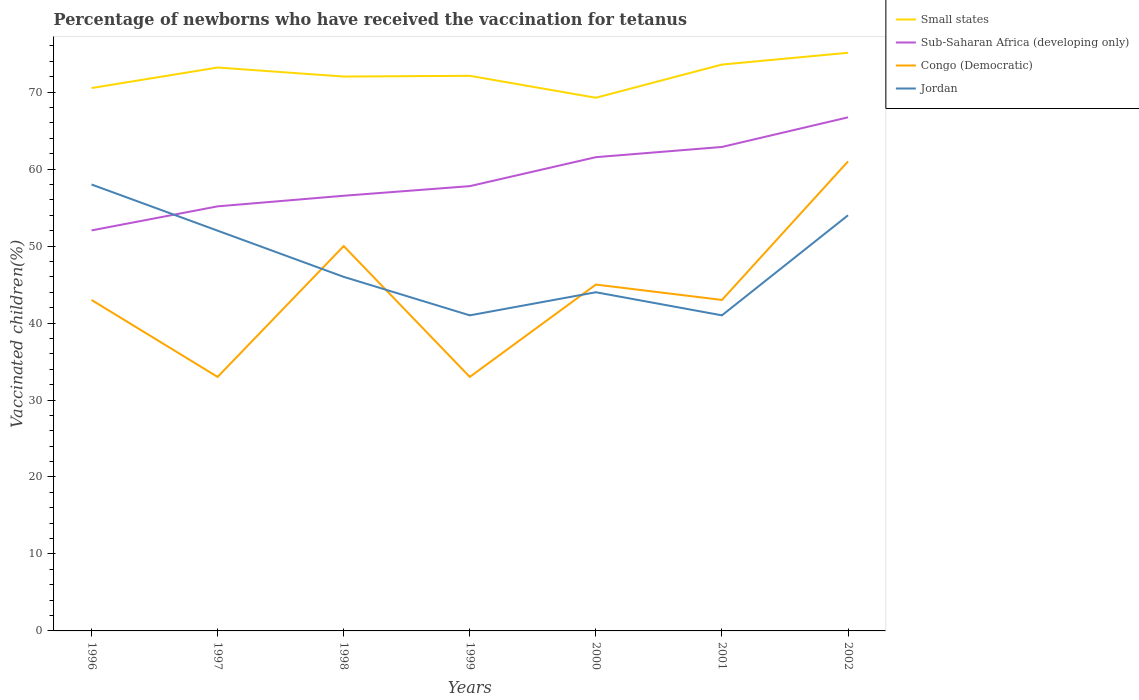How many different coloured lines are there?
Offer a very short reply. 4. Does the line corresponding to Congo (Democratic) intersect with the line corresponding to Small states?
Keep it short and to the point. No. In which year was the percentage of vaccinated children in Jordan maximum?
Your answer should be very brief. 1999. What is the total percentage of vaccinated children in Congo (Democratic) in the graph?
Offer a very short reply. -18. What is the difference between the highest and the second highest percentage of vaccinated children in Small states?
Make the answer very short. 5.84. Is the percentage of vaccinated children in Small states strictly greater than the percentage of vaccinated children in Sub-Saharan Africa (developing only) over the years?
Ensure brevity in your answer.  No. How many legend labels are there?
Offer a terse response. 4. What is the title of the graph?
Your answer should be very brief. Percentage of newborns who have received the vaccination for tetanus. What is the label or title of the Y-axis?
Offer a very short reply. Vaccinated children(%). What is the Vaccinated children(%) of Small states in 1996?
Keep it short and to the point. 70.53. What is the Vaccinated children(%) of Sub-Saharan Africa (developing only) in 1996?
Your answer should be compact. 52.04. What is the Vaccinated children(%) in Congo (Democratic) in 1996?
Give a very brief answer. 43. What is the Vaccinated children(%) of Jordan in 1996?
Keep it short and to the point. 58. What is the Vaccinated children(%) of Small states in 1997?
Provide a succinct answer. 73.2. What is the Vaccinated children(%) in Sub-Saharan Africa (developing only) in 1997?
Keep it short and to the point. 55.16. What is the Vaccinated children(%) in Congo (Democratic) in 1997?
Offer a very short reply. 33. What is the Vaccinated children(%) in Small states in 1998?
Keep it short and to the point. 72.03. What is the Vaccinated children(%) in Sub-Saharan Africa (developing only) in 1998?
Keep it short and to the point. 56.54. What is the Vaccinated children(%) of Congo (Democratic) in 1998?
Ensure brevity in your answer.  50. What is the Vaccinated children(%) in Small states in 1999?
Ensure brevity in your answer.  72.12. What is the Vaccinated children(%) of Sub-Saharan Africa (developing only) in 1999?
Keep it short and to the point. 57.79. What is the Vaccinated children(%) in Congo (Democratic) in 1999?
Ensure brevity in your answer.  33. What is the Vaccinated children(%) in Jordan in 1999?
Offer a terse response. 41. What is the Vaccinated children(%) of Small states in 2000?
Your answer should be very brief. 69.27. What is the Vaccinated children(%) of Sub-Saharan Africa (developing only) in 2000?
Your response must be concise. 61.55. What is the Vaccinated children(%) in Congo (Democratic) in 2000?
Keep it short and to the point. 45. What is the Vaccinated children(%) in Jordan in 2000?
Provide a succinct answer. 44. What is the Vaccinated children(%) in Small states in 2001?
Offer a terse response. 73.58. What is the Vaccinated children(%) in Sub-Saharan Africa (developing only) in 2001?
Make the answer very short. 62.88. What is the Vaccinated children(%) of Small states in 2002?
Make the answer very short. 75.11. What is the Vaccinated children(%) in Sub-Saharan Africa (developing only) in 2002?
Give a very brief answer. 66.73. Across all years, what is the maximum Vaccinated children(%) in Small states?
Your answer should be compact. 75.11. Across all years, what is the maximum Vaccinated children(%) in Sub-Saharan Africa (developing only)?
Your response must be concise. 66.73. Across all years, what is the maximum Vaccinated children(%) in Jordan?
Your response must be concise. 58. Across all years, what is the minimum Vaccinated children(%) of Small states?
Make the answer very short. 69.27. Across all years, what is the minimum Vaccinated children(%) in Sub-Saharan Africa (developing only)?
Provide a short and direct response. 52.04. Across all years, what is the minimum Vaccinated children(%) in Congo (Democratic)?
Ensure brevity in your answer.  33. What is the total Vaccinated children(%) in Small states in the graph?
Your response must be concise. 505.84. What is the total Vaccinated children(%) in Sub-Saharan Africa (developing only) in the graph?
Keep it short and to the point. 412.67. What is the total Vaccinated children(%) in Congo (Democratic) in the graph?
Make the answer very short. 308. What is the total Vaccinated children(%) in Jordan in the graph?
Your answer should be compact. 336. What is the difference between the Vaccinated children(%) in Small states in 1996 and that in 1997?
Offer a very short reply. -2.67. What is the difference between the Vaccinated children(%) in Sub-Saharan Africa (developing only) in 1996 and that in 1997?
Provide a succinct answer. -3.13. What is the difference between the Vaccinated children(%) in Congo (Democratic) in 1996 and that in 1997?
Ensure brevity in your answer.  10. What is the difference between the Vaccinated children(%) of Small states in 1996 and that in 1998?
Your answer should be very brief. -1.49. What is the difference between the Vaccinated children(%) in Sub-Saharan Africa (developing only) in 1996 and that in 1998?
Provide a succinct answer. -4.5. What is the difference between the Vaccinated children(%) in Congo (Democratic) in 1996 and that in 1998?
Ensure brevity in your answer.  -7. What is the difference between the Vaccinated children(%) in Small states in 1996 and that in 1999?
Your answer should be compact. -1.59. What is the difference between the Vaccinated children(%) of Sub-Saharan Africa (developing only) in 1996 and that in 1999?
Provide a succinct answer. -5.75. What is the difference between the Vaccinated children(%) of Congo (Democratic) in 1996 and that in 1999?
Provide a short and direct response. 10. What is the difference between the Vaccinated children(%) of Small states in 1996 and that in 2000?
Offer a very short reply. 1.26. What is the difference between the Vaccinated children(%) in Sub-Saharan Africa (developing only) in 1996 and that in 2000?
Your answer should be compact. -9.51. What is the difference between the Vaccinated children(%) in Congo (Democratic) in 1996 and that in 2000?
Keep it short and to the point. -2. What is the difference between the Vaccinated children(%) in Small states in 1996 and that in 2001?
Offer a very short reply. -3.05. What is the difference between the Vaccinated children(%) of Sub-Saharan Africa (developing only) in 1996 and that in 2001?
Ensure brevity in your answer.  -10.84. What is the difference between the Vaccinated children(%) of Congo (Democratic) in 1996 and that in 2001?
Provide a succinct answer. 0. What is the difference between the Vaccinated children(%) of Small states in 1996 and that in 2002?
Ensure brevity in your answer.  -4.58. What is the difference between the Vaccinated children(%) of Sub-Saharan Africa (developing only) in 1996 and that in 2002?
Offer a terse response. -14.69. What is the difference between the Vaccinated children(%) of Congo (Democratic) in 1996 and that in 2002?
Give a very brief answer. -18. What is the difference between the Vaccinated children(%) of Jordan in 1996 and that in 2002?
Offer a terse response. 4. What is the difference between the Vaccinated children(%) of Small states in 1997 and that in 1998?
Your answer should be very brief. 1.17. What is the difference between the Vaccinated children(%) of Sub-Saharan Africa (developing only) in 1997 and that in 1998?
Your response must be concise. -1.38. What is the difference between the Vaccinated children(%) in Jordan in 1997 and that in 1998?
Offer a very short reply. 6. What is the difference between the Vaccinated children(%) in Small states in 1997 and that in 1999?
Give a very brief answer. 1.08. What is the difference between the Vaccinated children(%) in Sub-Saharan Africa (developing only) in 1997 and that in 1999?
Offer a very short reply. -2.62. What is the difference between the Vaccinated children(%) in Congo (Democratic) in 1997 and that in 1999?
Keep it short and to the point. 0. What is the difference between the Vaccinated children(%) in Jordan in 1997 and that in 1999?
Make the answer very short. 11. What is the difference between the Vaccinated children(%) of Small states in 1997 and that in 2000?
Ensure brevity in your answer.  3.93. What is the difference between the Vaccinated children(%) of Sub-Saharan Africa (developing only) in 1997 and that in 2000?
Your answer should be compact. -6.39. What is the difference between the Vaccinated children(%) in Congo (Democratic) in 1997 and that in 2000?
Your response must be concise. -12. What is the difference between the Vaccinated children(%) of Jordan in 1997 and that in 2000?
Keep it short and to the point. 8. What is the difference between the Vaccinated children(%) in Small states in 1997 and that in 2001?
Ensure brevity in your answer.  -0.38. What is the difference between the Vaccinated children(%) in Sub-Saharan Africa (developing only) in 1997 and that in 2001?
Keep it short and to the point. -7.72. What is the difference between the Vaccinated children(%) in Jordan in 1997 and that in 2001?
Give a very brief answer. 11. What is the difference between the Vaccinated children(%) of Small states in 1997 and that in 2002?
Ensure brevity in your answer.  -1.92. What is the difference between the Vaccinated children(%) in Sub-Saharan Africa (developing only) in 1997 and that in 2002?
Your answer should be compact. -11.57. What is the difference between the Vaccinated children(%) of Small states in 1998 and that in 1999?
Keep it short and to the point. -0.09. What is the difference between the Vaccinated children(%) of Sub-Saharan Africa (developing only) in 1998 and that in 1999?
Offer a terse response. -1.25. What is the difference between the Vaccinated children(%) of Small states in 1998 and that in 2000?
Make the answer very short. 2.75. What is the difference between the Vaccinated children(%) of Sub-Saharan Africa (developing only) in 1998 and that in 2000?
Your answer should be very brief. -5.01. What is the difference between the Vaccinated children(%) of Congo (Democratic) in 1998 and that in 2000?
Your response must be concise. 5. What is the difference between the Vaccinated children(%) in Jordan in 1998 and that in 2000?
Keep it short and to the point. 2. What is the difference between the Vaccinated children(%) of Small states in 1998 and that in 2001?
Offer a terse response. -1.56. What is the difference between the Vaccinated children(%) in Sub-Saharan Africa (developing only) in 1998 and that in 2001?
Offer a terse response. -6.34. What is the difference between the Vaccinated children(%) in Congo (Democratic) in 1998 and that in 2001?
Offer a very short reply. 7. What is the difference between the Vaccinated children(%) in Small states in 1998 and that in 2002?
Offer a terse response. -3.09. What is the difference between the Vaccinated children(%) of Sub-Saharan Africa (developing only) in 1998 and that in 2002?
Offer a very short reply. -10.19. What is the difference between the Vaccinated children(%) of Jordan in 1998 and that in 2002?
Make the answer very short. -8. What is the difference between the Vaccinated children(%) in Small states in 1999 and that in 2000?
Make the answer very short. 2.85. What is the difference between the Vaccinated children(%) of Sub-Saharan Africa (developing only) in 1999 and that in 2000?
Offer a very short reply. -3.76. What is the difference between the Vaccinated children(%) in Small states in 1999 and that in 2001?
Offer a terse response. -1.46. What is the difference between the Vaccinated children(%) in Sub-Saharan Africa (developing only) in 1999 and that in 2001?
Provide a short and direct response. -5.09. What is the difference between the Vaccinated children(%) in Jordan in 1999 and that in 2001?
Offer a very short reply. 0. What is the difference between the Vaccinated children(%) in Small states in 1999 and that in 2002?
Provide a succinct answer. -2.99. What is the difference between the Vaccinated children(%) of Sub-Saharan Africa (developing only) in 1999 and that in 2002?
Ensure brevity in your answer.  -8.94. What is the difference between the Vaccinated children(%) in Jordan in 1999 and that in 2002?
Offer a very short reply. -13. What is the difference between the Vaccinated children(%) of Small states in 2000 and that in 2001?
Your response must be concise. -4.31. What is the difference between the Vaccinated children(%) in Sub-Saharan Africa (developing only) in 2000 and that in 2001?
Make the answer very short. -1.33. What is the difference between the Vaccinated children(%) of Small states in 2000 and that in 2002?
Provide a succinct answer. -5.84. What is the difference between the Vaccinated children(%) in Sub-Saharan Africa (developing only) in 2000 and that in 2002?
Your answer should be very brief. -5.18. What is the difference between the Vaccinated children(%) of Jordan in 2000 and that in 2002?
Ensure brevity in your answer.  -10. What is the difference between the Vaccinated children(%) of Small states in 2001 and that in 2002?
Make the answer very short. -1.53. What is the difference between the Vaccinated children(%) of Sub-Saharan Africa (developing only) in 2001 and that in 2002?
Keep it short and to the point. -3.85. What is the difference between the Vaccinated children(%) in Congo (Democratic) in 2001 and that in 2002?
Give a very brief answer. -18. What is the difference between the Vaccinated children(%) in Small states in 1996 and the Vaccinated children(%) in Sub-Saharan Africa (developing only) in 1997?
Your response must be concise. 15.37. What is the difference between the Vaccinated children(%) in Small states in 1996 and the Vaccinated children(%) in Congo (Democratic) in 1997?
Your response must be concise. 37.53. What is the difference between the Vaccinated children(%) in Small states in 1996 and the Vaccinated children(%) in Jordan in 1997?
Your answer should be very brief. 18.53. What is the difference between the Vaccinated children(%) in Sub-Saharan Africa (developing only) in 1996 and the Vaccinated children(%) in Congo (Democratic) in 1997?
Make the answer very short. 19.04. What is the difference between the Vaccinated children(%) of Sub-Saharan Africa (developing only) in 1996 and the Vaccinated children(%) of Jordan in 1997?
Your answer should be very brief. 0.04. What is the difference between the Vaccinated children(%) in Small states in 1996 and the Vaccinated children(%) in Sub-Saharan Africa (developing only) in 1998?
Offer a very short reply. 13.99. What is the difference between the Vaccinated children(%) of Small states in 1996 and the Vaccinated children(%) of Congo (Democratic) in 1998?
Keep it short and to the point. 20.53. What is the difference between the Vaccinated children(%) in Small states in 1996 and the Vaccinated children(%) in Jordan in 1998?
Offer a terse response. 24.53. What is the difference between the Vaccinated children(%) in Sub-Saharan Africa (developing only) in 1996 and the Vaccinated children(%) in Congo (Democratic) in 1998?
Offer a very short reply. 2.04. What is the difference between the Vaccinated children(%) of Sub-Saharan Africa (developing only) in 1996 and the Vaccinated children(%) of Jordan in 1998?
Provide a short and direct response. 6.04. What is the difference between the Vaccinated children(%) in Congo (Democratic) in 1996 and the Vaccinated children(%) in Jordan in 1998?
Your response must be concise. -3. What is the difference between the Vaccinated children(%) of Small states in 1996 and the Vaccinated children(%) of Sub-Saharan Africa (developing only) in 1999?
Provide a succinct answer. 12.75. What is the difference between the Vaccinated children(%) in Small states in 1996 and the Vaccinated children(%) in Congo (Democratic) in 1999?
Provide a short and direct response. 37.53. What is the difference between the Vaccinated children(%) of Small states in 1996 and the Vaccinated children(%) of Jordan in 1999?
Offer a terse response. 29.53. What is the difference between the Vaccinated children(%) in Sub-Saharan Africa (developing only) in 1996 and the Vaccinated children(%) in Congo (Democratic) in 1999?
Make the answer very short. 19.04. What is the difference between the Vaccinated children(%) of Sub-Saharan Africa (developing only) in 1996 and the Vaccinated children(%) of Jordan in 1999?
Offer a very short reply. 11.04. What is the difference between the Vaccinated children(%) in Small states in 1996 and the Vaccinated children(%) in Sub-Saharan Africa (developing only) in 2000?
Provide a succinct answer. 8.98. What is the difference between the Vaccinated children(%) in Small states in 1996 and the Vaccinated children(%) in Congo (Democratic) in 2000?
Keep it short and to the point. 25.53. What is the difference between the Vaccinated children(%) in Small states in 1996 and the Vaccinated children(%) in Jordan in 2000?
Provide a short and direct response. 26.53. What is the difference between the Vaccinated children(%) of Sub-Saharan Africa (developing only) in 1996 and the Vaccinated children(%) of Congo (Democratic) in 2000?
Give a very brief answer. 7.04. What is the difference between the Vaccinated children(%) of Sub-Saharan Africa (developing only) in 1996 and the Vaccinated children(%) of Jordan in 2000?
Offer a terse response. 8.04. What is the difference between the Vaccinated children(%) in Congo (Democratic) in 1996 and the Vaccinated children(%) in Jordan in 2000?
Make the answer very short. -1. What is the difference between the Vaccinated children(%) of Small states in 1996 and the Vaccinated children(%) of Sub-Saharan Africa (developing only) in 2001?
Your answer should be very brief. 7.65. What is the difference between the Vaccinated children(%) of Small states in 1996 and the Vaccinated children(%) of Congo (Democratic) in 2001?
Make the answer very short. 27.53. What is the difference between the Vaccinated children(%) of Small states in 1996 and the Vaccinated children(%) of Jordan in 2001?
Ensure brevity in your answer.  29.53. What is the difference between the Vaccinated children(%) in Sub-Saharan Africa (developing only) in 1996 and the Vaccinated children(%) in Congo (Democratic) in 2001?
Give a very brief answer. 9.04. What is the difference between the Vaccinated children(%) of Sub-Saharan Africa (developing only) in 1996 and the Vaccinated children(%) of Jordan in 2001?
Offer a very short reply. 11.04. What is the difference between the Vaccinated children(%) of Congo (Democratic) in 1996 and the Vaccinated children(%) of Jordan in 2001?
Provide a succinct answer. 2. What is the difference between the Vaccinated children(%) of Small states in 1996 and the Vaccinated children(%) of Sub-Saharan Africa (developing only) in 2002?
Offer a very short reply. 3.8. What is the difference between the Vaccinated children(%) in Small states in 1996 and the Vaccinated children(%) in Congo (Democratic) in 2002?
Offer a terse response. 9.53. What is the difference between the Vaccinated children(%) of Small states in 1996 and the Vaccinated children(%) of Jordan in 2002?
Provide a succinct answer. 16.53. What is the difference between the Vaccinated children(%) in Sub-Saharan Africa (developing only) in 1996 and the Vaccinated children(%) in Congo (Democratic) in 2002?
Offer a terse response. -8.96. What is the difference between the Vaccinated children(%) in Sub-Saharan Africa (developing only) in 1996 and the Vaccinated children(%) in Jordan in 2002?
Ensure brevity in your answer.  -1.96. What is the difference between the Vaccinated children(%) in Small states in 1997 and the Vaccinated children(%) in Sub-Saharan Africa (developing only) in 1998?
Your response must be concise. 16.66. What is the difference between the Vaccinated children(%) in Small states in 1997 and the Vaccinated children(%) in Congo (Democratic) in 1998?
Keep it short and to the point. 23.2. What is the difference between the Vaccinated children(%) of Small states in 1997 and the Vaccinated children(%) of Jordan in 1998?
Offer a very short reply. 27.2. What is the difference between the Vaccinated children(%) of Sub-Saharan Africa (developing only) in 1997 and the Vaccinated children(%) of Congo (Democratic) in 1998?
Your answer should be very brief. 5.16. What is the difference between the Vaccinated children(%) of Sub-Saharan Africa (developing only) in 1997 and the Vaccinated children(%) of Jordan in 1998?
Your response must be concise. 9.16. What is the difference between the Vaccinated children(%) of Congo (Democratic) in 1997 and the Vaccinated children(%) of Jordan in 1998?
Your answer should be compact. -13. What is the difference between the Vaccinated children(%) of Small states in 1997 and the Vaccinated children(%) of Sub-Saharan Africa (developing only) in 1999?
Make the answer very short. 15.41. What is the difference between the Vaccinated children(%) of Small states in 1997 and the Vaccinated children(%) of Congo (Democratic) in 1999?
Your answer should be very brief. 40.2. What is the difference between the Vaccinated children(%) in Small states in 1997 and the Vaccinated children(%) in Jordan in 1999?
Your answer should be compact. 32.2. What is the difference between the Vaccinated children(%) in Sub-Saharan Africa (developing only) in 1997 and the Vaccinated children(%) in Congo (Democratic) in 1999?
Make the answer very short. 22.16. What is the difference between the Vaccinated children(%) in Sub-Saharan Africa (developing only) in 1997 and the Vaccinated children(%) in Jordan in 1999?
Offer a terse response. 14.16. What is the difference between the Vaccinated children(%) in Small states in 1997 and the Vaccinated children(%) in Sub-Saharan Africa (developing only) in 2000?
Your answer should be compact. 11.65. What is the difference between the Vaccinated children(%) in Small states in 1997 and the Vaccinated children(%) in Congo (Democratic) in 2000?
Provide a succinct answer. 28.2. What is the difference between the Vaccinated children(%) in Small states in 1997 and the Vaccinated children(%) in Jordan in 2000?
Your answer should be very brief. 29.2. What is the difference between the Vaccinated children(%) of Sub-Saharan Africa (developing only) in 1997 and the Vaccinated children(%) of Congo (Democratic) in 2000?
Provide a short and direct response. 10.16. What is the difference between the Vaccinated children(%) in Sub-Saharan Africa (developing only) in 1997 and the Vaccinated children(%) in Jordan in 2000?
Ensure brevity in your answer.  11.16. What is the difference between the Vaccinated children(%) in Small states in 1997 and the Vaccinated children(%) in Sub-Saharan Africa (developing only) in 2001?
Make the answer very short. 10.32. What is the difference between the Vaccinated children(%) in Small states in 1997 and the Vaccinated children(%) in Congo (Democratic) in 2001?
Your answer should be very brief. 30.2. What is the difference between the Vaccinated children(%) of Small states in 1997 and the Vaccinated children(%) of Jordan in 2001?
Your answer should be compact. 32.2. What is the difference between the Vaccinated children(%) of Sub-Saharan Africa (developing only) in 1997 and the Vaccinated children(%) of Congo (Democratic) in 2001?
Provide a short and direct response. 12.16. What is the difference between the Vaccinated children(%) of Sub-Saharan Africa (developing only) in 1997 and the Vaccinated children(%) of Jordan in 2001?
Keep it short and to the point. 14.16. What is the difference between the Vaccinated children(%) of Congo (Democratic) in 1997 and the Vaccinated children(%) of Jordan in 2001?
Offer a terse response. -8. What is the difference between the Vaccinated children(%) of Small states in 1997 and the Vaccinated children(%) of Sub-Saharan Africa (developing only) in 2002?
Offer a terse response. 6.47. What is the difference between the Vaccinated children(%) of Small states in 1997 and the Vaccinated children(%) of Congo (Democratic) in 2002?
Give a very brief answer. 12.2. What is the difference between the Vaccinated children(%) of Small states in 1997 and the Vaccinated children(%) of Jordan in 2002?
Your answer should be compact. 19.2. What is the difference between the Vaccinated children(%) in Sub-Saharan Africa (developing only) in 1997 and the Vaccinated children(%) in Congo (Democratic) in 2002?
Provide a short and direct response. -5.84. What is the difference between the Vaccinated children(%) of Sub-Saharan Africa (developing only) in 1997 and the Vaccinated children(%) of Jordan in 2002?
Keep it short and to the point. 1.16. What is the difference between the Vaccinated children(%) of Congo (Democratic) in 1997 and the Vaccinated children(%) of Jordan in 2002?
Offer a very short reply. -21. What is the difference between the Vaccinated children(%) of Small states in 1998 and the Vaccinated children(%) of Sub-Saharan Africa (developing only) in 1999?
Offer a very short reply. 14.24. What is the difference between the Vaccinated children(%) of Small states in 1998 and the Vaccinated children(%) of Congo (Democratic) in 1999?
Provide a short and direct response. 39.03. What is the difference between the Vaccinated children(%) in Small states in 1998 and the Vaccinated children(%) in Jordan in 1999?
Offer a very short reply. 31.03. What is the difference between the Vaccinated children(%) in Sub-Saharan Africa (developing only) in 1998 and the Vaccinated children(%) in Congo (Democratic) in 1999?
Provide a short and direct response. 23.54. What is the difference between the Vaccinated children(%) of Sub-Saharan Africa (developing only) in 1998 and the Vaccinated children(%) of Jordan in 1999?
Offer a terse response. 15.54. What is the difference between the Vaccinated children(%) of Small states in 1998 and the Vaccinated children(%) of Sub-Saharan Africa (developing only) in 2000?
Make the answer very short. 10.48. What is the difference between the Vaccinated children(%) in Small states in 1998 and the Vaccinated children(%) in Congo (Democratic) in 2000?
Offer a very short reply. 27.03. What is the difference between the Vaccinated children(%) in Small states in 1998 and the Vaccinated children(%) in Jordan in 2000?
Make the answer very short. 28.03. What is the difference between the Vaccinated children(%) in Sub-Saharan Africa (developing only) in 1998 and the Vaccinated children(%) in Congo (Democratic) in 2000?
Make the answer very short. 11.54. What is the difference between the Vaccinated children(%) of Sub-Saharan Africa (developing only) in 1998 and the Vaccinated children(%) of Jordan in 2000?
Keep it short and to the point. 12.54. What is the difference between the Vaccinated children(%) in Small states in 1998 and the Vaccinated children(%) in Sub-Saharan Africa (developing only) in 2001?
Your answer should be very brief. 9.15. What is the difference between the Vaccinated children(%) of Small states in 1998 and the Vaccinated children(%) of Congo (Democratic) in 2001?
Your answer should be very brief. 29.03. What is the difference between the Vaccinated children(%) in Small states in 1998 and the Vaccinated children(%) in Jordan in 2001?
Offer a very short reply. 31.03. What is the difference between the Vaccinated children(%) of Sub-Saharan Africa (developing only) in 1998 and the Vaccinated children(%) of Congo (Democratic) in 2001?
Your answer should be very brief. 13.54. What is the difference between the Vaccinated children(%) of Sub-Saharan Africa (developing only) in 1998 and the Vaccinated children(%) of Jordan in 2001?
Your answer should be compact. 15.54. What is the difference between the Vaccinated children(%) of Small states in 1998 and the Vaccinated children(%) of Sub-Saharan Africa (developing only) in 2002?
Provide a short and direct response. 5.3. What is the difference between the Vaccinated children(%) of Small states in 1998 and the Vaccinated children(%) of Congo (Democratic) in 2002?
Your answer should be very brief. 11.03. What is the difference between the Vaccinated children(%) of Small states in 1998 and the Vaccinated children(%) of Jordan in 2002?
Provide a succinct answer. 18.03. What is the difference between the Vaccinated children(%) of Sub-Saharan Africa (developing only) in 1998 and the Vaccinated children(%) of Congo (Democratic) in 2002?
Your answer should be compact. -4.46. What is the difference between the Vaccinated children(%) in Sub-Saharan Africa (developing only) in 1998 and the Vaccinated children(%) in Jordan in 2002?
Your response must be concise. 2.54. What is the difference between the Vaccinated children(%) in Small states in 1999 and the Vaccinated children(%) in Sub-Saharan Africa (developing only) in 2000?
Keep it short and to the point. 10.57. What is the difference between the Vaccinated children(%) of Small states in 1999 and the Vaccinated children(%) of Congo (Democratic) in 2000?
Your response must be concise. 27.12. What is the difference between the Vaccinated children(%) in Small states in 1999 and the Vaccinated children(%) in Jordan in 2000?
Keep it short and to the point. 28.12. What is the difference between the Vaccinated children(%) in Sub-Saharan Africa (developing only) in 1999 and the Vaccinated children(%) in Congo (Democratic) in 2000?
Your answer should be very brief. 12.79. What is the difference between the Vaccinated children(%) in Sub-Saharan Africa (developing only) in 1999 and the Vaccinated children(%) in Jordan in 2000?
Provide a succinct answer. 13.79. What is the difference between the Vaccinated children(%) of Congo (Democratic) in 1999 and the Vaccinated children(%) of Jordan in 2000?
Your answer should be compact. -11. What is the difference between the Vaccinated children(%) in Small states in 1999 and the Vaccinated children(%) in Sub-Saharan Africa (developing only) in 2001?
Provide a short and direct response. 9.24. What is the difference between the Vaccinated children(%) in Small states in 1999 and the Vaccinated children(%) in Congo (Democratic) in 2001?
Ensure brevity in your answer.  29.12. What is the difference between the Vaccinated children(%) of Small states in 1999 and the Vaccinated children(%) of Jordan in 2001?
Give a very brief answer. 31.12. What is the difference between the Vaccinated children(%) of Sub-Saharan Africa (developing only) in 1999 and the Vaccinated children(%) of Congo (Democratic) in 2001?
Offer a terse response. 14.79. What is the difference between the Vaccinated children(%) in Sub-Saharan Africa (developing only) in 1999 and the Vaccinated children(%) in Jordan in 2001?
Make the answer very short. 16.79. What is the difference between the Vaccinated children(%) of Small states in 1999 and the Vaccinated children(%) of Sub-Saharan Africa (developing only) in 2002?
Make the answer very short. 5.39. What is the difference between the Vaccinated children(%) in Small states in 1999 and the Vaccinated children(%) in Congo (Democratic) in 2002?
Make the answer very short. 11.12. What is the difference between the Vaccinated children(%) in Small states in 1999 and the Vaccinated children(%) in Jordan in 2002?
Provide a succinct answer. 18.12. What is the difference between the Vaccinated children(%) of Sub-Saharan Africa (developing only) in 1999 and the Vaccinated children(%) of Congo (Democratic) in 2002?
Ensure brevity in your answer.  -3.21. What is the difference between the Vaccinated children(%) in Sub-Saharan Africa (developing only) in 1999 and the Vaccinated children(%) in Jordan in 2002?
Offer a terse response. 3.79. What is the difference between the Vaccinated children(%) in Small states in 2000 and the Vaccinated children(%) in Sub-Saharan Africa (developing only) in 2001?
Offer a terse response. 6.39. What is the difference between the Vaccinated children(%) in Small states in 2000 and the Vaccinated children(%) in Congo (Democratic) in 2001?
Provide a short and direct response. 26.27. What is the difference between the Vaccinated children(%) of Small states in 2000 and the Vaccinated children(%) of Jordan in 2001?
Offer a terse response. 28.27. What is the difference between the Vaccinated children(%) of Sub-Saharan Africa (developing only) in 2000 and the Vaccinated children(%) of Congo (Democratic) in 2001?
Your response must be concise. 18.55. What is the difference between the Vaccinated children(%) in Sub-Saharan Africa (developing only) in 2000 and the Vaccinated children(%) in Jordan in 2001?
Offer a very short reply. 20.55. What is the difference between the Vaccinated children(%) of Congo (Democratic) in 2000 and the Vaccinated children(%) of Jordan in 2001?
Offer a very short reply. 4. What is the difference between the Vaccinated children(%) in Small states in 2000 and the Vaccinated children(%) in Sub-Saharan Africa (developing only) in 2002?
Your answer should be very brief. 2.54. What is the difference between the Vaccinated children(%) of Small states in 2000 and the Vaccinated children(%) of Congo (Democratic) in 2002?
Your answer should be very brief. 8.27. What is the difference between the Vaccinated children(%) in Small states in 2000 and the Vaccinated children(%) in Jordan in 2002?
Offer a terse response. 15.27. What is the difference between the Vaccinated children(%) of Sub-Saharan Africa (developing only) in 2000 and the Vaccinated children(%) of Congo (Democratic) in 2002?
Give a very brief answer. 0.55. What is the difference between the Vaccinated children(%) in Sub-Saharan Africa (developing only) in 2000 and the Vaccinated children(%) in Jordan in 2002?
Offer a very short reply. 7.55. What is the difference between the Vaccinated children(%) in Small states in 2001 and the Vaccinated children(%) in Sub-Saharan Africa (developing only) in 2002?
Make the answer very short. 6.85. What is the difference between the Vaccinated children(%) of Small states in 2001 and the Vaccinated children(%) of Congo (Democratic) in 2002?
Provide a succinct answer. 12.58. What is the difference between the Vaccinated children(%) of Small states in 2001 and the Vaccinated children(%) of Jordan in 2002?
Offer a terse response. 19.58. What is the difference between the Vaccinated children(%) of Sub-Saharan Africa (developing only) in 2001 and the Vaccinated children(%) of Congo (Democratic) in 2002?
Offer a terse response. 1.88. What is the difference between the Vaccinated children(%) in Sub-Saharan Africa (developing only) in 2001 and the Vaccinated children(%) in Jordan in 2002?
Provide a succinct answer. 8.88. What is the average Vaccinated children(%) of Small states per year?
Provide a succinct answer. 72.26. What is the average Vaccinated children(%) of Sub-Saharan Africa (developing only) per year?
Make the answer very short. 58.95. What is the average Vaccinated children(%) in Congo (Democratic) per year?
Your answer should be compact. 44. What is the average Vaccinated children(%) of Jordan per year?
Your response must be concise. 48. In the year 1996, what is the difference between the Vaccinated children(%) in Small states and Vaccinated children(%) in Sub-Saharan Africa (developing only)?
Your answer should be compact. 18.5. In the year 1996, what is the difference between the Vaccinated children(%) in Small states and Vaccinated children(%) in Congo (Democratic)?
Keep it short and to the point. 27.53. In the year 1996, what is the difference between the Vaccinated children(%) in Small states and Vaccinated children(%) in Jordan?
Make the answer very short. 12.53. In the year 1996, what is the difference between the Vaccinated children(%) in Sub-Saharan Africa (developing only) and Vaccinated children(%) in Congo (Democratic)?
Give a very brief answer. 9.04. In the year 1996, what is the difference between the Vaccinated children(%) in Sub-Saharan Africa (developing only) and Vaccinated children(%) in Jordan?
Offer a very short reply. -5.96. In the year 1996, what is the difference between the Vaccinated children(%) of Congo (Democratic) and Vaccinated children(%) of Jordan?
Your answer should be compact. -15. In the year 1997, what is the difference between the Vaccinated children(%) in Small states and Vaccinated children(%) in Sub-Saharan Africa (developing only)?
Your answer should be very brief. 18.04. In the year 1997, what is the difference between the Vaccinated children(%) of Small states and Vaccinated children(%) of Congo (Democratic)?
Keep it short and to the point. 40.2. In the year 1997, what is the difference between the Vaccinated children(%) in Small states and Vaccinated children(%) in Jordan?
Offer a very short reply. 21.2. In the year 1997, what is the difference between the Vaccinated children(%) of Sub-Saharan Africa (developing only) and Vaccinated children(%) of Congo (Democratic)?
Give a very brief answer. 22.16. In the year 1997, what is the difference between the Vaccinated children(%) in Sub-Saharan Africa (developing only) and Vaccinated children(%) in Jordan?
Your answer should be very brief. 3.16. In the year 1998, what is the difference between the Vaccinated children(%) of Small states and Vaccinated children(%) of Sub-Saharan Africa (developing only)?
Ensure brevity in your answer.  15.49. In the year 1998, what is the difference between the Vaccinated children(%) in Small states and Vaccinated children(%) in Congo (Democratic)?
Your answer should be very brief. 22.03. In the year 1998, what is the difference between the Vaccinated children(%) in Small states and Vaccinated children(%) in Jordan?
Offer a very short reply. 26.03. In the year 1998, what is the difference between the Vaccinated children(%) of Sub-Saharan Africa (developing only) and Vaccinated children(%) of Congo (Democratic)?
Offer a very short reply. 6.54. In the year 1998, what is the difference between the Vaccinated children(%) of Sub-Saharan Africa (developing only) and Vaccinated children(%) of Jordan?
Make the answer very short. 10.54. In the year 1999, what is the difference between the Vaccinated children(%) of Small states and Vaccinated children(%) of Sub-Saharan Africa (developing only)?
Your answer should be compact. 14.33. In the year 1999, what is the difference between the Vaccinated children(%) of Small states and Vaccinated children(%) of Congo (Democratic)?
Ensure brevity in your answer.  39.12. In the year 1999, what is the difference between the Vaccinated children(%) in Small states and Vaccinated children(%) in Jordan?
Your answer should be very brief. 31.12. In the year 1999, what is the difference between the Vaccinated children(%) in Sub-Saharan Africa (developing only) and Vaccinated children(%) in Congo (Democratic)?
Offer a terse response. 24.79. In the year 1999, what is the difference between the Vaccinated children(%) in Sub-Saharan Africa (developing only) and Vaccinated children(%) in Jordan?
Provide a succinct answer. 16.79. In the year 2000, what is the difference between the Vaccinated children(%) in Small states and Vaccinated children(%) in Sub-Saharan Africa (developing only)?
Ensure brevity in your answer.  7.72. In the year 2000, what is the difference between the Vaccinated children(%) in Small states and Vaccinated children(%) in Congo (Democratic)?
Keep it short and to the point. 24.27. In the year 2000, what is the difference between the Vaccinated children(%) in Small states and Vaccinated children(%) in Jordan?
Make the answer very short. 25.27. In the year 2000, what is the difference between the Vaccinated children(%) in Sub-Saharan Africa (developing only) and Vaccinated children(%) in Congo (Democratic)?
Your answer should be compact. 16.55. In the year 2000, what is the difference between the Vaccinated children(%) in Sub-Saharan Africa (developing only) and Vaccinated children(%) in Jordan?
Keep it short and to the point. 17.55. In the year 2001, what is the difference between the Vaccinated children(%) of Small states and Vaccinated children(%) of Sub-Saharan Africa (developing only)?
Make the answer very short. 10.7. In the year 2001, what is the difference between the Vaccinated children(%) in Small states and Vaccinated children(%) in Congo (Democratic)?
Provide a succinct answer. 30.58. In the year 2001, what is the difference between the Vaccinated children(%) in Small states and Vaccinated children(%) in Jordan?
Provide a short and direct response. 32.58. In the year 2001, what is the difference between the Vaccinated children(%) of Sub-Saharan Africa (developing only) and Vaccinated children(%) of Congo (Democratic)?
Your answer should be very brief. 19.88. In the year 2001, what is the difference between the Vaccinated children(%) of Sub-Saharan Africa (developing only) and Vaccinated children(%) of Jordan?
Provide a short and direct response. 21.88. In the year 2002, what is the difference between the Vaccinated children(%) of Small states and Vaccinated children(%) of Sub-Saharan Africa (developing only)?
Give a very brief answer. 8.39. In the year 2002, what is the difference between the Vaccinated children(%) in Small states and Vaccinated children(%) in Congo (Democratic)?
Provide a short and direct response. 14.11. In the year 2002, what is the difference between the Vaccinated children(%) in Small states and Vaccinated children(%) in Jordan?
Offer a very short reply. 21.11. In the year 2002, what is the difference between the Vaccinated children(%) of Sub-Saharan Africa (developing only) and Vaccinated children(%) of Congo (Democratic)?
Offer a very short reply. 5.73. In the year 2002, what is the difference between the Vaccinated children(%) in Sub-Saharan Africa (developing only) and Vaccinated children(%) in Jordan?
Provide a succinct answer. 12.73. What is the ratio of the Vaccinated children(%) of Small states in 1996 to that in 1997?
Offer a terse response. 0.96. What is the ratio of the Vaccinated children(%) in Sub-Saharan Africa (developing only) in 1996 to that in 1997?
Keep it short and to the point. 0.94. What is the ratio of the Vaccinated children(%) in Congo (Democratic) in 1996 to that in 1997?
Make the answer very short. 1.3. What is the ratio of the Vaccinated children(%) in Jordan in 1996 to that in 1997?
Your response must be concise. 1.12. What is the ratio of the Vaccinated children(%) in Small states in 1996 to that in 1998?
Make the answer very short. 0.98. What is the ratio of the Vaccinated children(%) in Sub-Saharan Africa (developing only) in 1996 to that in 1998?
Make the answer very short. 0.92. What is the ratio of the Vaccinated children(%) of Congo (Democratic) in 1996 to that in 1998?
Give a very brief answer. 0.86. What is the ratio of the Vaccinated children(%) of Jordan in 1996 to that in 1998?
Ensure brevity in your answer.  1.26. What is the ratio of the Vaccinated children(%) of Small states in 1996 to that in 1999?
Offer a terse response. 0.98. What is the ratio of the Vaccinated children(%) of Sub-Saharan Africa (developing only) in 1996 to that in 1999?
Keep it short and to the point. 0.9. What is the ratio of the Vaccinated children(%) in Congo (Democratic) in 1996 to that in 1999?
Provide a short and direct response. 1.3. What is the ratio of the Vaccinated children(%) in Jordan in 1996 to that in 1999?
Offer a very short reply. 1.41. What is the ratio of the Vaccinated children(%) in Small states in 1996 to that in 2000?
Offer a very short reply. 1.02. What is the ratio of the Vaccinated children(%) of Sub-Saharan Africa (developing only) in 1996 to that in 2000?
Keep it short and to the point. 0.85. What is the ratio of the Vaccinated children(%) in Congo (Democratic) in 1996 to that in 2000?
Keep it short and to the point. 0.96. What is the ratio of the Vaccinated children(%) of Jordan in 1996 to that in 2000?
Provide a succinct answer. 1.32. What is the ratio of the Vaccinated children(%) in Small states in 1996 to that in 2001?
Ensure brevity in your answer.  0.96. What is the ratio of the Vaccinated children(%) in Sub-Saharan Africa (developing only) in 1996 to that in 2001?
Your response must be concise. 0.83. What is the ratio of the Vaccinated children(%) of Jordan in 1996 to that in 2001?
Offer a terse response. 1.41. What is the ratio of the Vaccinated children(%) of Small states in 1996 to that in 2002?
Provide a short and direct response. 0.94. What is the ratio of the Vaccinated children(%) of Sub-Saharan Africa (developing only) in 1996 to that in 2002?
Offer a very short reply. 0.78. What is the ratio of the Vaccinated children(%) of Congo (Democratic) in 1996 to that in 2002?
Ensure brevity in your answer.  0.7. What is the ratio of the Vaccinated children(%) in Jordan in 1996 to that in 2002?
Provide a short and direct response. 1.07. What is the ratio of the Vaccinated children(%) in Small states in 1997 to that in 1998?
Provide a short and direct response. 1.02. What is the ratio of the Vaccinated children(%) in Sub-Saharan Africa (developing only) in 1997 to that in 1998?
Offer a very short reply. 0.98. What is the ratio of the Vaccinated children(%) of Congo (Democratic) in 1997 to that in 1998?
Provide a short and direct response. 0.66. What is the ratio of the Vaccinated children(%) in Jordan in 1997 to that in 1998?
Give a very brief answer. 1.13. What is the ratio of the Vaccinated children(%) in Small states in 1997 to that in 1999?
Provide a short and direct response. 1.01. What is the ratio of the Vaccinated children(%) of Sub-Saharan Africa (developing only) in 1997 to that in 1999?
Offer a terse response. 0.95. What is the ratio of the Vaccinated children(%) in Congo (Democratic) in 1997 to that in 1999?
Your answer should be very brief. 1. What is the ratio of the Vaccinated children(%) of Jordan in 1997 to that in 1999?
Keep it short and to the point. 1.27. What is the ratio of the Vaccinated children(%) of Small states in 1997 to that in 2000?
Your answer should be very brief. 1.06. What is the ratio of the Vaccinated children(%) in Sub-Saharan Africa (developing only) in 1997 to that in 2000?
Offer a very short reply. 0.9. What is the ratio of the Vaccinated children(%) in Congo (Democratic) in 1997 to that in 2000?
Make the answer very short. 0.73. What is the ratio of the Vaccinated children(%) of Jordan in 1997 to that in 2000?
Keep it short and to the point. 1.18. What is the ratio of the Vaccinated children(%) in Small states in 1997 to that in 2001?
Keep it short and to the point. 0.99. What is the ratio of the Vaccinated children(%) in Sub-Saharan Africa (developing only) in 1997 to that in 2001?
Ensure brevity in your answer.  0.88. What is the ratio of the Vaccinated children(%) in Congo (Democratic) in 1997 to that in 2001?
Keep it short and to the point. 0.77. What is the ratio of the Vaccinated children(%) in Jordan in 1997 to that in 2001?
Your answer should be compact. 1.27. What is the ratio of the Vaccinated children(%) in Small states in 1997 to that in 2002?
Your answer should be very brief. 0.97. What is the ratio of the Vaccinated children(%) in Sub-Saharan Africa (developing only) in 1997 to that in 2002?
Offer a terse response. 0.83. What is the ratio of the Vaccinated children(%) of Congo (Democratic) in 1997 to that in 2002?
Offer a terse response. 0.54. What is the ratio of the Vaccinated children(%) of Jordan in 1997 to that in 2002?
Offer a very short reply. 0.96. What is the ratio of the Vaccinated children(%) of Small states in 1998 to that in 1999?
Keep it short and to the point. 1. What is the ratio of the Vaccinated children(%) of Sub-Saharan Africa (developing only) in 1998 to that in 1999?
Your answer should be compact. 0.98. What is the ratio of the Vaccinated children(%) of Congo (Democratic) in 1998 to that in 1999?
Your answer should be very brief. 1.52. What is the ratio of the Vaccinated children(%) of Jordan in 1998 to that in 1999?
Make the answer very short. 1.12. What is the ratio of the Vaccinated children(%) in Small states in 1998 to that in 2000?
Your answer should be very brief. 1.04. What is the ratio of the Vaccinated children(%) of Sub-Saharan Africa (developing only) in 1998 to that in 2000?
Ensure brevity in your answer.  0.92. What is the ratio of the Vaccinated children(%) in Jordan in 1998 to that in 2000?
Keep it short and to the point. 1.05. What is the ratio of the Vaccinated children(%) of Small states in 1998 to that in 2001?
Your response must be concise. 0.98. What is the ratio of the Vaccinated children(%) in Sub-Saharan Africa (developing only) in 1998 to that in 2001?
Provide a succinct answer. 0.9. What is the ratio of the Vaccinated children(%) in Congo (Democratic) in 1998 to that in 2001?
Ensure brevity in your answer.  1.16. What is the ratio of the Vaccinated children(%) in Jordan in 1998 to that in 2001?
Provide a succinct answer. 1.12. What is the ratio of the Vaccinated children(%) in Small states in 1998 to that in 2002?
Your response must be concise. 0.96. What is the ratio of the Vaccinated children(%) in Sub-Saharan Africa (developing only) in 1998 to that in 2002?
Keep it short and to the point. 0.85. What is the ratio of the Vaccinated children(%) of Congo (Democratic) in 1998 to that in 2002?
Your answer should be very brief. 0.82. What is the ratio of the Vaccinated children(%) in Jordan in 1998 to that in 2002?
Your answer should be compact. 0.85. What is the ratio of the Vaccinated children(%) of Small states in 1999 to that in 2000?
Give a very brief answer. 1.04. What is the ratio of the Vaccinated children(%) of Sub-Saharan Africa (developing only) in 1999 to that in 2000?
Provide a short and direct response. 0.94. What is the ratio of the Vaccinated children(%) in Congo (Democratic) in 1999 to that in 2000?
Ensure brevity in your answer.  0.73. What is the ratio of the Vaccinated children(%) in Jordan in 1999 to that in 2000?
Offer a terse response. 0.93. What is the ratio of the Vaccinated children(%) in Small states in 1999 to that in 2001?
Keep it short and to the point. 0.98. What is the ratio of the Vaccinated children(%) in Sub-Saharan Africa (developing only) in 1999 to that in 2001?
Offer a very short reply. 0.92. What is the ratio of the Vaccinated children(%) in Congo (Democratic) in 1999 to that in 2001?
Ensure brevity in your answer.  0.77. What is the ratio of the Vaccinated children(%) in Jordan in 1999 to that in 2001?
Ensure brevity in your answer.  1. What is the ratio of the Vaccinated children(%) in Small states in 1999 to that in 2002?
Provide a succinct answer. 0.96. What is the ratio of the Vaccinated children(%) of Sub-Saharan Africa (developing only) in 1999 to that in 2002?
Offer a very short reply. 0.87. What is the ratio of the Vaccinated children(%) in Congo (Democratic) in 1999 to that in 2002?
Provide a short and direct response. 0.54. What is the ratio of the Vaccinated children(%) of Jordan in 1999 to that in 2002?
Keep it short and to the point. 0.76. What is the ratio of the Vaccinated children(%) of Small states in 2000 to that in 2001?
Your answer should be very brief. 0.94. What is the ratio of the Vaccinated children(%) of Sub-Saharan Africa (developing only) in 2000 to that in 2001?
Provide a short and direct response. 0.98. What is the ratio of the Vaccinated children(%) of Congo (Democratic) in 2000 to that in 2001?
Offer a terse response. 1.05. What is the ratio of the Vaccinated children(%) in Jordan in 2000 to that in 2001?
Offer a very short reply. 1.07. What is the ratio of the Vaccinated children(%) in Small states in 2000 to that in 2002?
Provide a short and direct response. 0.92. What is the ratio of the Vaccinated children(%) in Sub-Saharan Africa (developing only) in 2000 to that in 2002?
Your answer should be very brief. 0.92. What is the ratio of the Vaccinated children(%) in Congo (Democratic) in 2000 to that in 2002?
Keep it short and to the point. 0.74. What is the ratio of the Vaccinated children(%) of Jordan in 2000 to that in 2002?
Offer a terse response. 0.81. What is the ratio of the Vaccinated children(%) in Small states in 2001 to that in 2002?
Provide a succinct answer. 0.98. What is the ratio of the Vaccinated children(%) of Sub-Saharan Africa (developing only) in 2001 to that in 2002?
Ensure brevity in your answer.  0.94. What is the ratio of the Vaccinated children(%) of Congo (Democratic) in 2001 to that in 2002?
Give a very brief answer. 0.7. What is the ratio of the Vaccinated children(%) of Jordan in 2001 to that in 2002?
Provide a short and direct response. 0.76. What is the difference between the highest and the second highest Vaccinated children(%) of Small states?
Provide a succinct answer. 1.53. What is the difference between the highest and the second highest Vaccinated children(%) of Sub-Saharan Africa (developing only)?
Offer a very short reply. 3.85. What is the difference between the highest and the second highest Vaccinated children(%) in Congo (Democratic)?
Offer a very short reply. 11. What is the difference between the highest and the second highest Vaccinated children(%) of Jordan?
Keep it short and to the point. 4. What is the difference between the highest and the lowest Vaccinated children(%) in Small states?
Provide a succinct answer. 5.84. What is the difference between the highest and the lowest Vaccinated children(%) of Sub-Saharan Africa (developing only)?
Make the answer very short. 14.69. What is the difference between the highest and the lowest Vaccinated children(%) of Congo (Democratic)?
Provide a short and direct response. 28. What is the difference between the highest and the lowest Vaccinated children(%) of Jordan?
Your answer should be very brief. 17. 